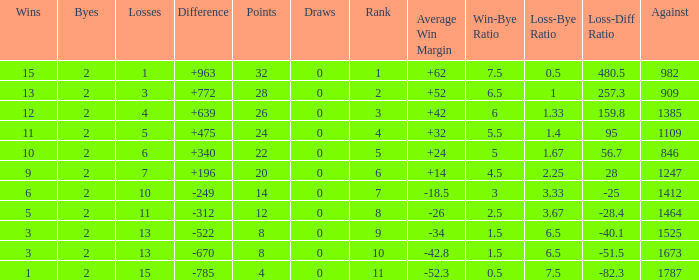What is the highest number listed under against when there were less than 3 wins and less than 15 losses? None. 